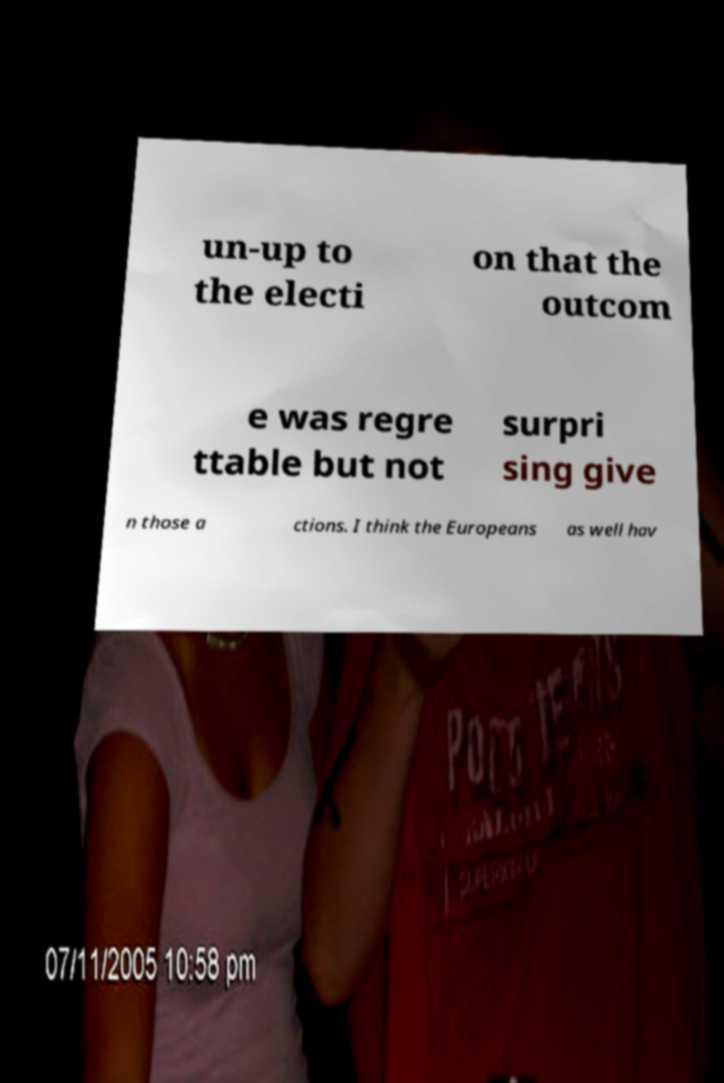Please identify and transcribe the text found in this image. un-up to the electi on that the outcom e was regre ttable but not surpri sing give n those a ctions. I think the Europeans as well hav 